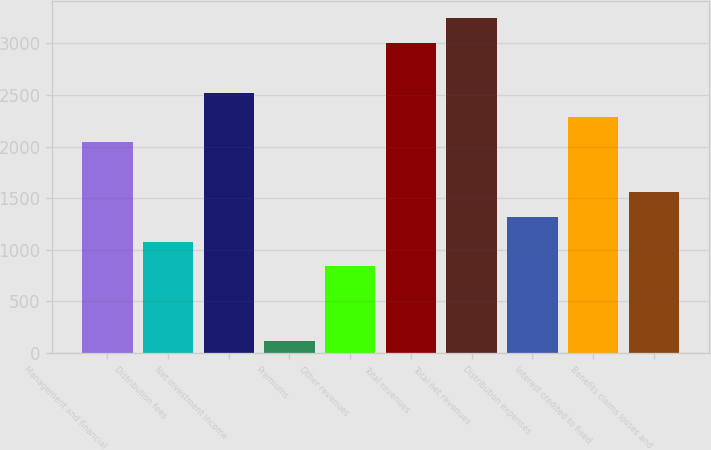Convert chart to OTSL. <chart><loc_0><loc_0><loc_500><loc_500><bar_chart><fcel>Management and financial<fcel>Distribution fees<fcel>Net investment income<fcel>Premiums<fcel>Other revenues<fcel>Total revenues<fcel>Total net revenues<fcel>Distribution expenses<fcel>Interest credited to fixed<fcel>Benefits claims losses and<nl><fcel>2042.8<fcel>1080.4<fcel>2524<fcel>118<fcel>839.8<fcel>3005.2<fcel>3245.8<fcel>1321<fcel>2283.4<fcel>1561.6<nl></chart> 